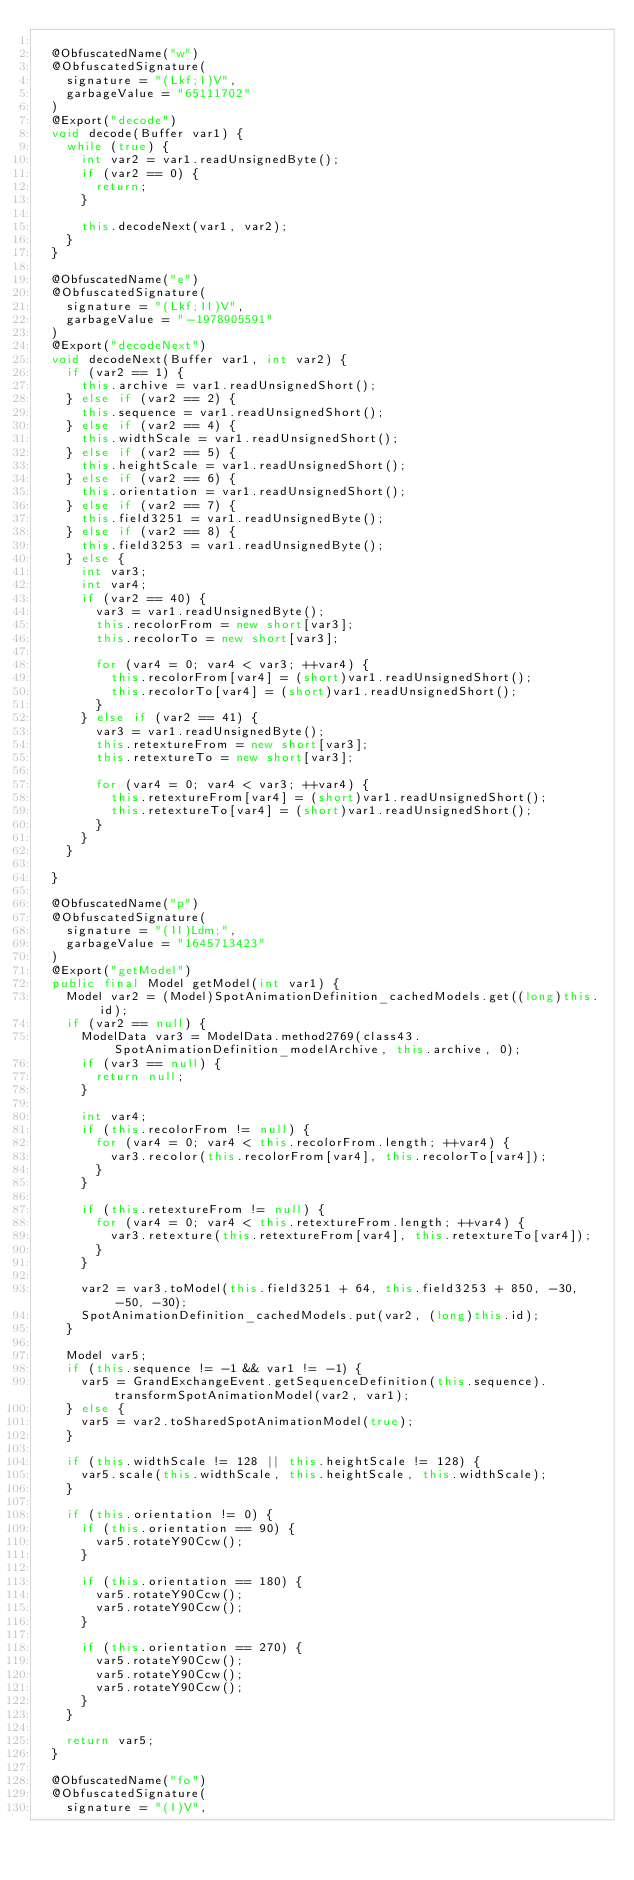<code> <loc_0><loc_0><loc_500><loc_500><_Java_>
	@ObfuscatedName("w")
	@ObfuscatedSignature(
		signature = "(Lkf;I)V",
		garbageValue = "65111702"
	)
	@Export("decode")
	void decode(Buffer var1) {
		while (true) {
			int var2 = var1.readUnsignedByte();
			if (var2 == 0) {
				return;
			}

			this.decodeNext(var1, var2);
		}
	}

	@ObfuscatedName("e")
	@ObfuscatedSignature(
		signature = "(Lkf;II)V",
		garbageValue = "-1978905591"
	)
	@Export("decodeNext")
	void decodeNext(Buffer var1, int var2) {
		if (var2 == 1) {
			this.archive = var1.readUnsignedShort();
		} else if (var2 == 2) {
			this.sequence = var1.readUnsignedShort();
		} else if (var2 == 4) {
			this.widthScale = var1.readUnsignedShort();
		} else if (var2 == 5) {
			this.heightScale = var1.readUnsignedShort();
		} else if (var2 == 6) {
			this.orientation = var1.readUnsignedShort();
		} else if (var2 == 7) {
			this.field3251 = var1.readUnsignedByte();
		} else if (var2 == 8) {
			this.field3253 = var1.readUnsignedByte();
		} else {
			int var3;
			int var4;
			if (var2 == 40) {
				var3 = var1.readUnsignedByte();
				this.recolorFrom = new short[var3];
				this.recolorTo = new short[var3];

				for (var4 = 0; var4 < var3; ++var4) {
					this.recolorFrom[var4] = (short)var1.readUnsignedShort();
					this.recolorTo[var4] = (short)var1.readUnsignedShort();
				}
			} else if (var2 == 41) {
				var3 = var1.readUnsignedByte();
				this.retextureFrom = new short[var3];
				this.retextureTo = new short[var3];

				for (var4 = 0; var4 < var3; ++var4) {
					this.retextureFrom[var4] = (short)var1.readUnsignedShort();
					this.retextureTo[var4] = (short)var1.readUnsignedShort();
				}
			}
		}

	}

	@ObfuscatedName("p")
	@ObfuscatedSignature(
		signature = "(II)Ldm;",
		garbageValue = "1645713423"
	)
	@Export("getModel")
	public final Model getModel(int var1) {
		Model var2 = (Model)SpotAnimationDefinition_cachedModels.get((long)this.id);
		if (var2 == null) {
			ModelData var3 = ModelData.method2769(class43.SpotAnimationDefinition_modelArchive, this.archive, 0);
			if (var3 == null) {
				return null;
			}

			int var4;
			if (this.recolorFrom != null) {
				for (var4 = 0; var4 < this.recolorFrom.length; ++var4) {
					var3.recolor(this.recolorFrom[var4], this.recolorTo[var4]);
				}
			}

			if (this.retextureFrom != null) {
				for (var4 = 0; var4 < this.retextureFrom.length; ++var4) {
					var3.retexture(this.retextureFrom[var4], this.retextureTo[var4]);
				}
			}

			var2 = var3.toModel(this.field3251 + 64, this.field3253 + 850, -30, -50, -30);
			SpotAnimationDefinition_cachedModels.put(var2, (long)this.id);
		}

		Model var5;
		if (this.sequence != -1 && var1 != -1) {
			var5 = GrandExchangeEvent.getSequenceDefinition(this.sequence).transformSpotAnimationModel(var2, var1);
		} else {
			var5 = var2.toSharedSpotAnimationModel(true);
		}

		if (this.widthScale != 128 || this.heightScale != 128) {
			var5.scale(this.widthScale, this.heightScale, this.widthScale);
		}

		if (this.orientation != 0) {
			if (this.orientation == 90) {
				var5.rotateY90Ccw();
			}

			if (this.orientation == 180) {
				var5.rotateY90Ccw();
				var5.rotateY90Ccw();
			}

			if (this.orientation == 270) {
				var5.rotateY90Ccw();
				var5.rotateY90Ccw();
				var5.rotateY90Ccw();
			}
		}

		return var5;
	}

	@ObfuscatedName("fo")
	@ObfuscatedSignature(
		signature = "(I)V",</code> 